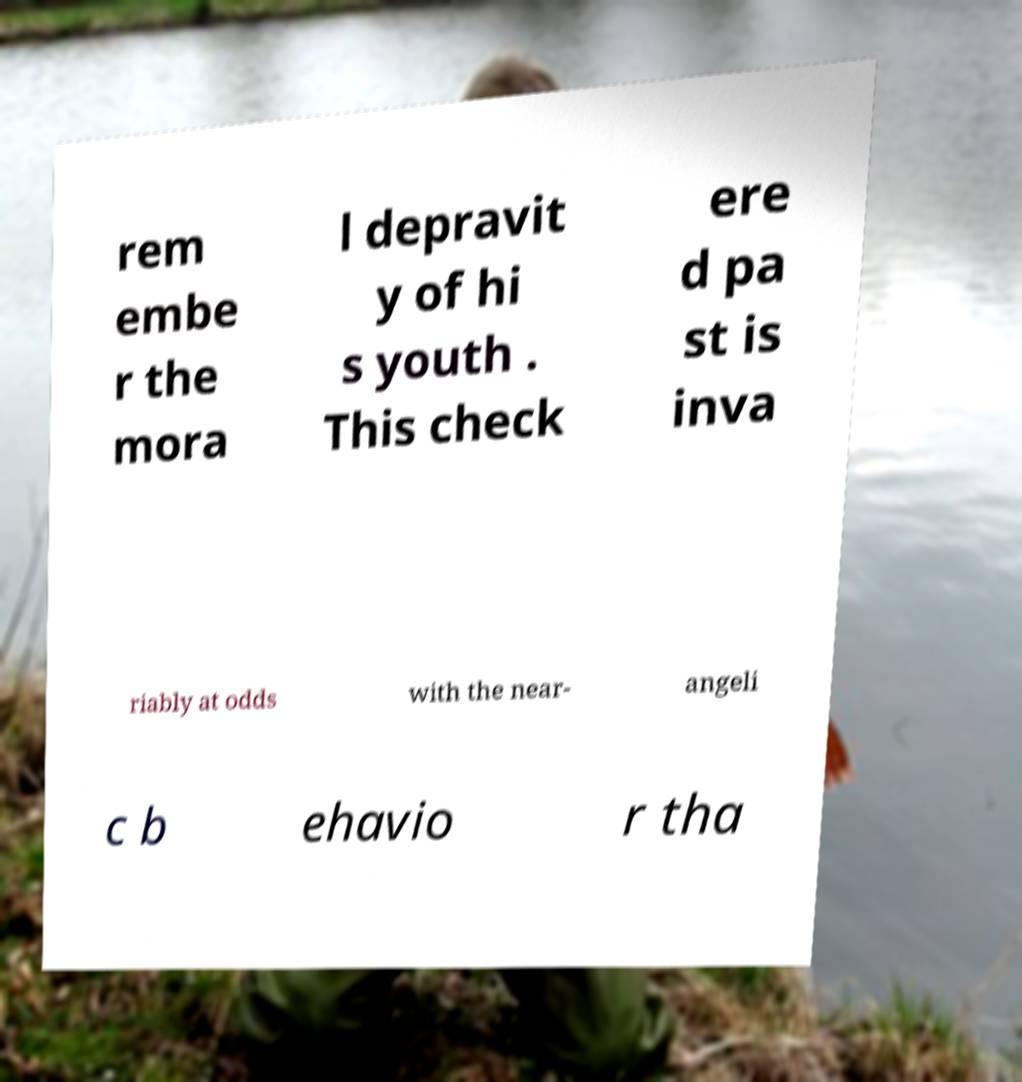Please read and relay the text visible in this image. What does it say? rem embe r the mora l depravit y of hi s youth . This check ere d pa st is inva riably at odds with the near- angeli c b ehavio r tha 